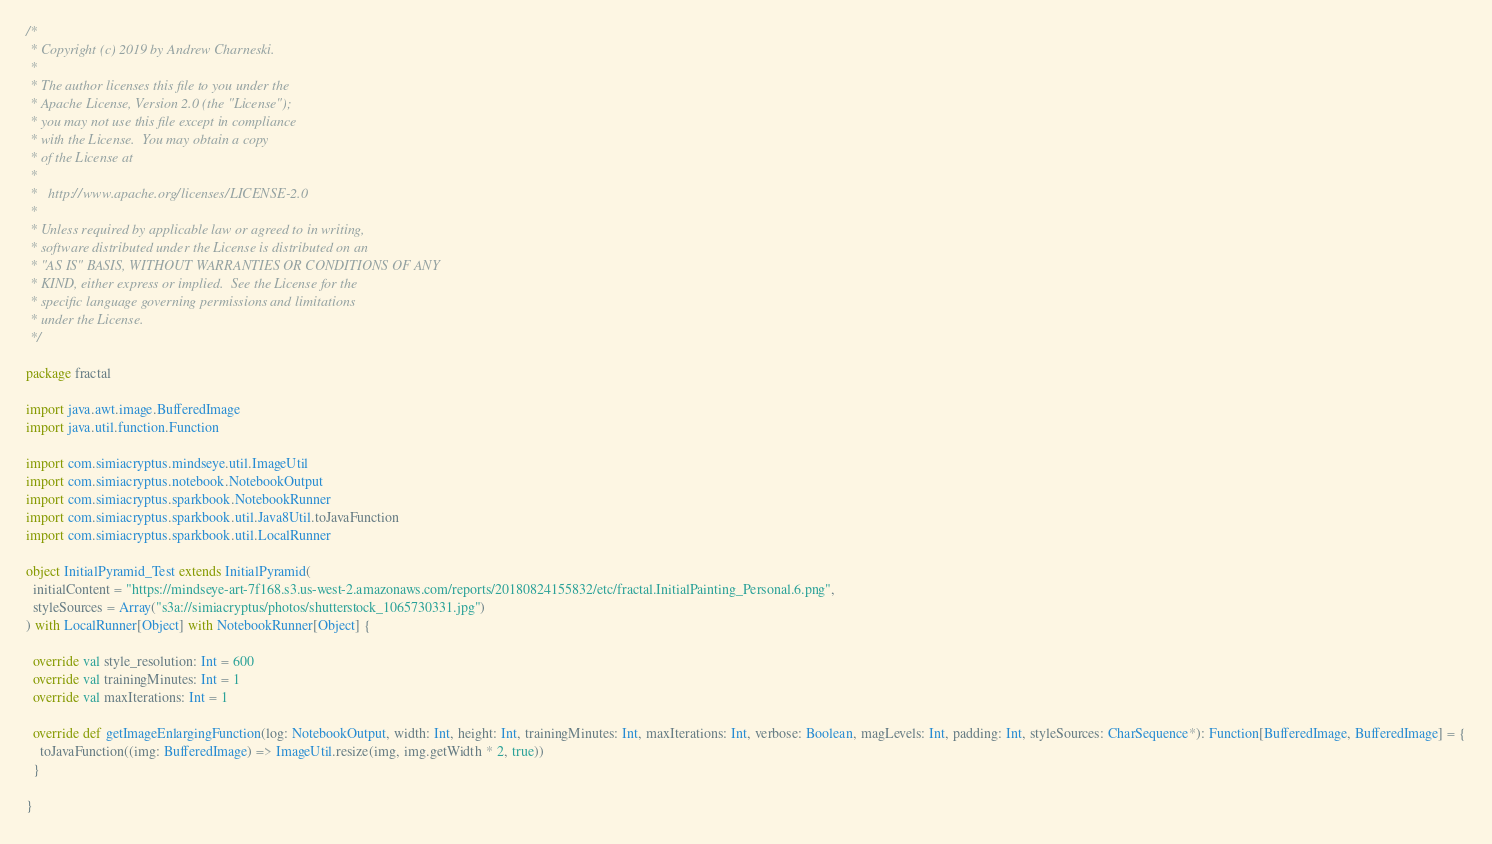Convert code to text. <code><loc_0><loc_0><loc_500><loc_500><_Scala_>/*
 * Copyright (c) 2019 by Andrew Charneski.
 *
 * The author licenses this file to you under the
 * Apache License, Version 2.0 (the "License");
 * you may not use this file except in compliance
 * with the License.  You may obtain a copy
 * of the License at
 *
 *   http://www.apache.org/licenses/LICENSE-2.0
 *
 * Unless required by applicable law or agreed to in writing,
 * software distributed under the License is distributed on an
 * "AS IS" BASIS, WITHOUT WARRANTIES OR CONDITIONS OF ANY
 * KIND, either express or implied.  See the License for the
 * specific language governing permissions and limitations
 * under the License.
 */

package fractal

import java.awt.image.BufferedImage
import java.util.function.Function

import com.simiacryptus.mindseye.util.ImageUtil
import com.simiacryptus.notebook.NotebookOutput
import com.simiacryptus.sparkbook.NotebookRunner
import com.simiacryptus.sparkbook.util.Java8Util.toJavaFunction
import com.simiacryptus.sparkbook.util.LocalRunner

object InitialPyramid_Test extends InitialPyramid(
  initialContent = "https://mindseye-art-7f168.s3.us-west-2.amazonaws.com/reports/20180824155832/etc/fractal.InitialPainting_Personal.6.png",
  styleSources = Array("s3a://simiacryptus/photos/shutterstock_1065730331.jpg")
) with LocalRunner[Object] with NotebookRunner[Object] {

  override val style_resolution: Int = 600
  override val trainingMinutes: Int = 1
  override val maxIterations: Int = 1

  override def getImageEnlargingFunction(log: NotebookOutput, width: Int, height: Int, trainingMinutes: Int, maxIterations: Int, verbose: Boolean, magLevels: Int, padding: Int, styleSources: CharSequence*): Function[BufferedImage, BufferedImage] = {
    toJavaFunction((img: BufferedImage) => ImageUtil.resize(img, img.getWidth * 2, true))
  }

}
</code> 